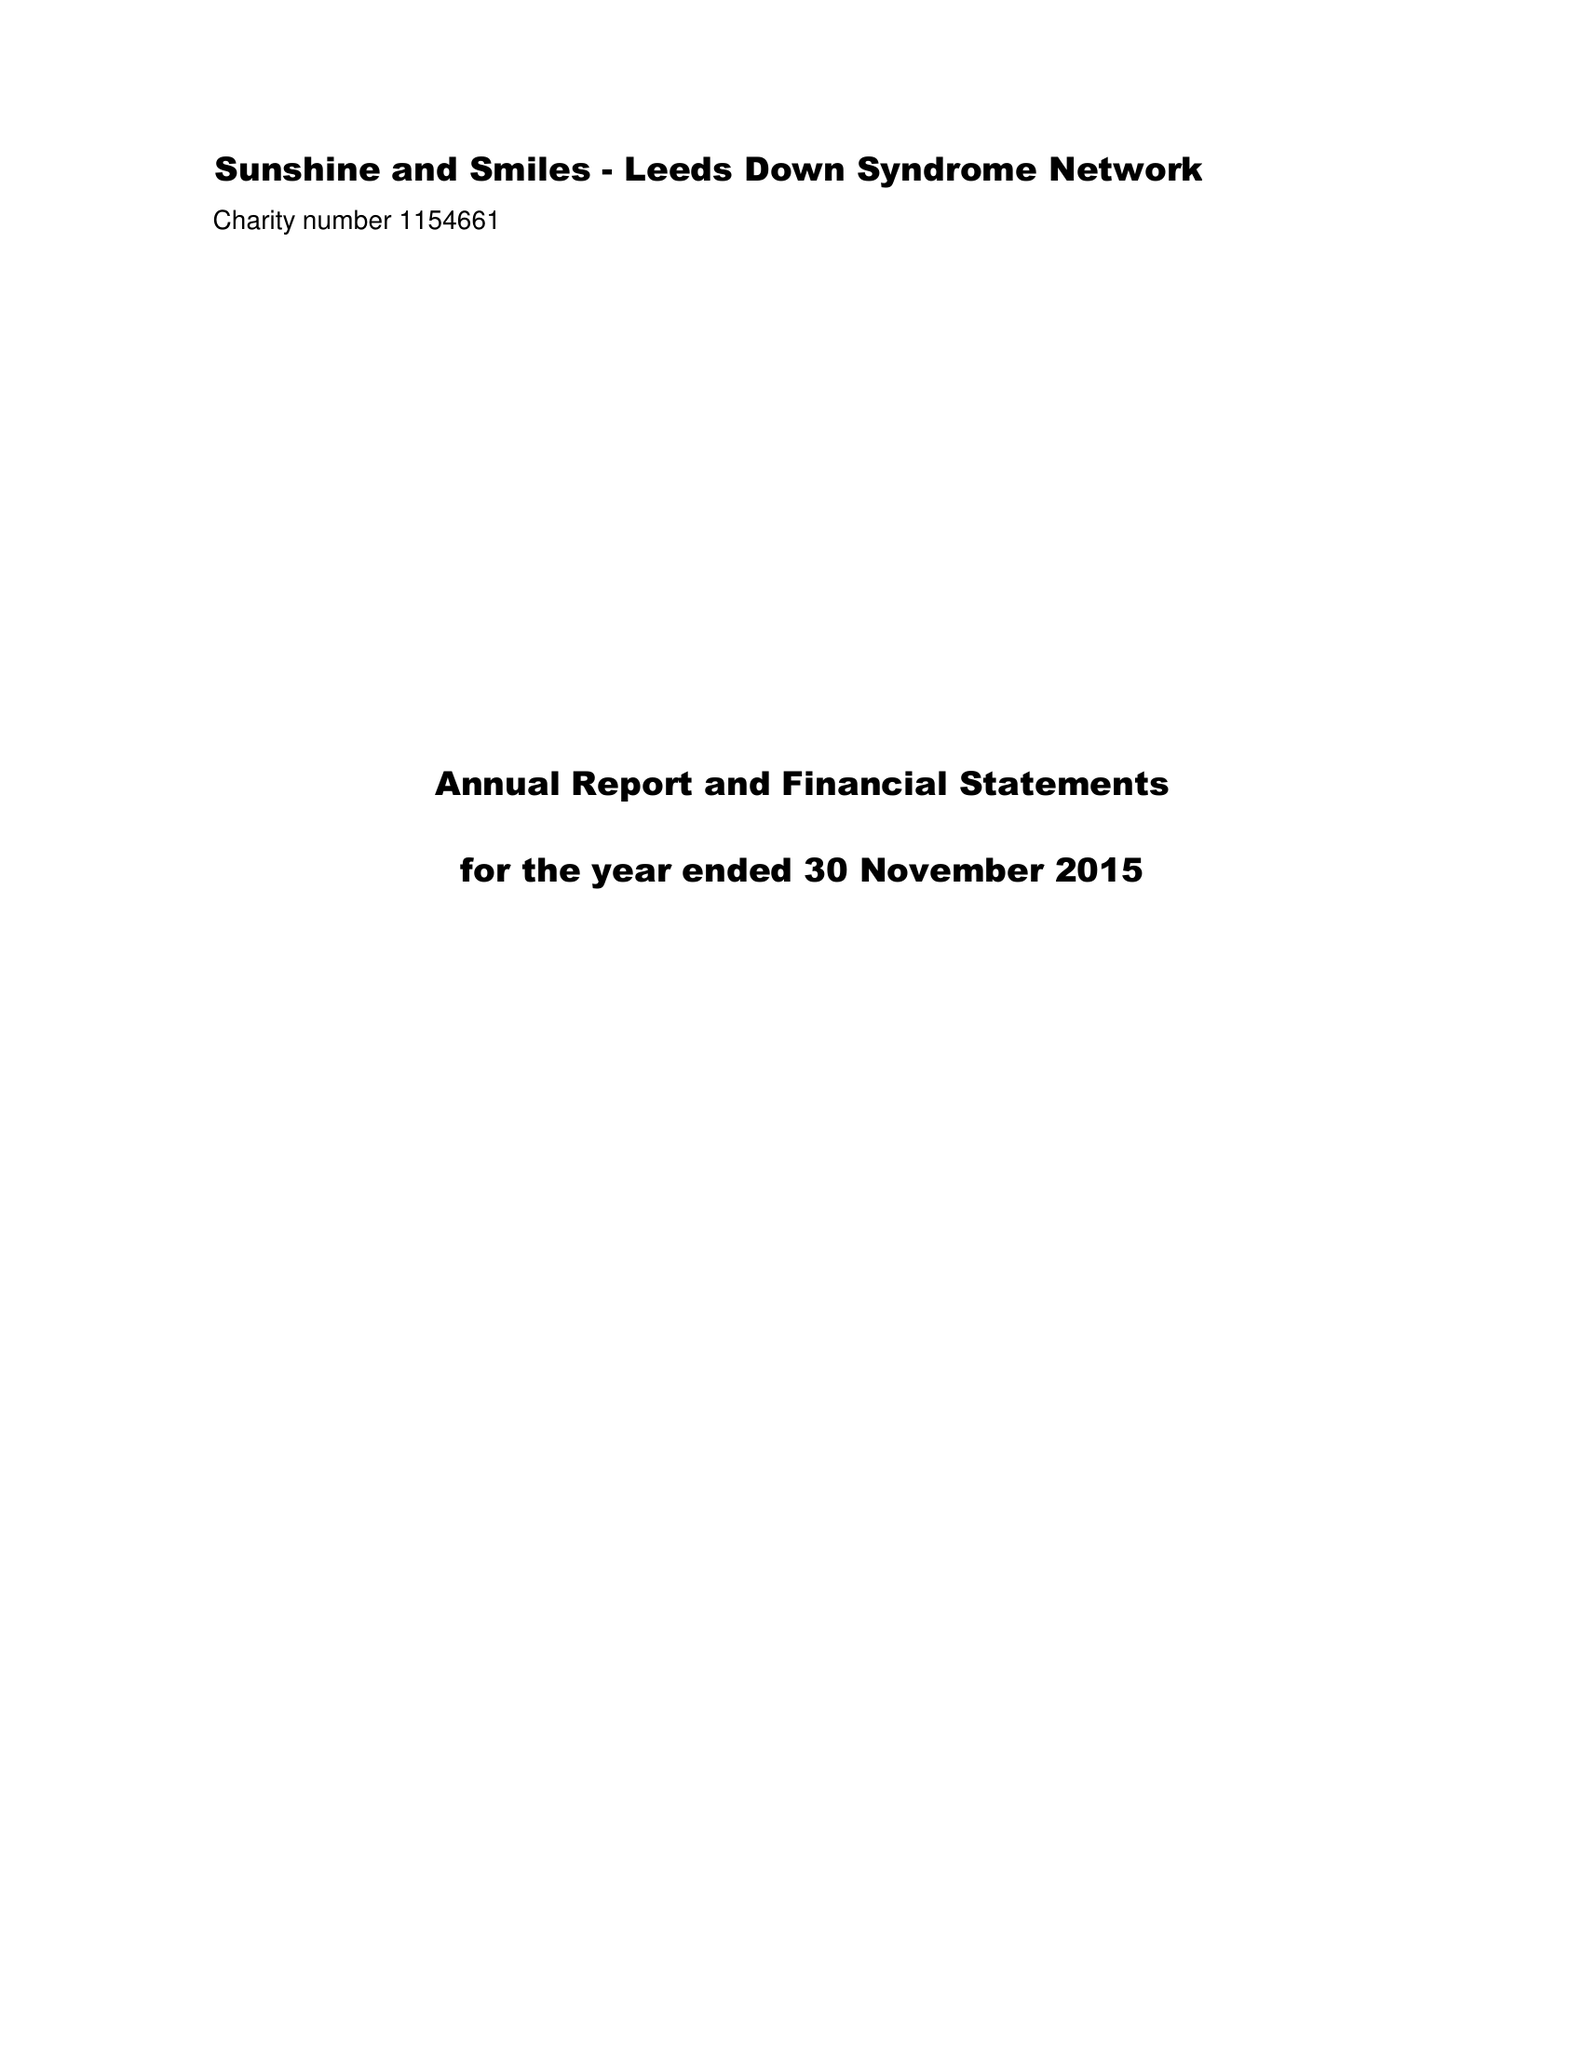What is the value for the report_date?
Answer the question using a single word or phrase. 2015-11-30 